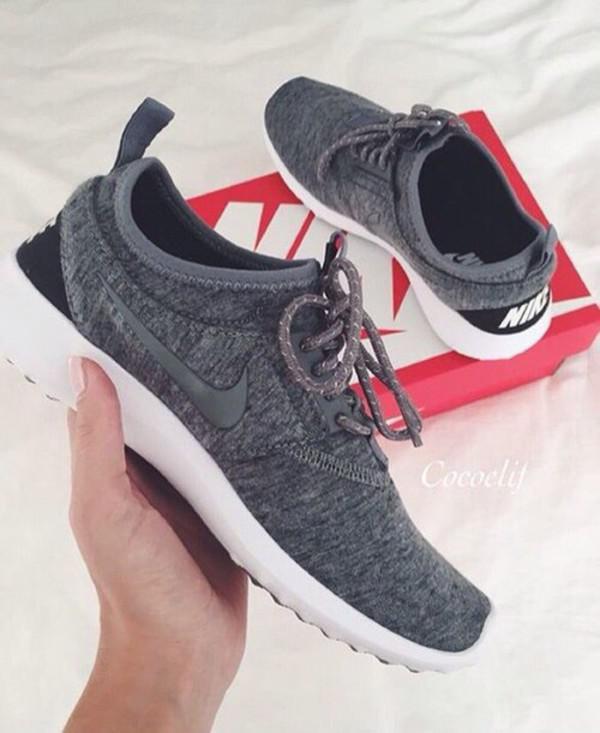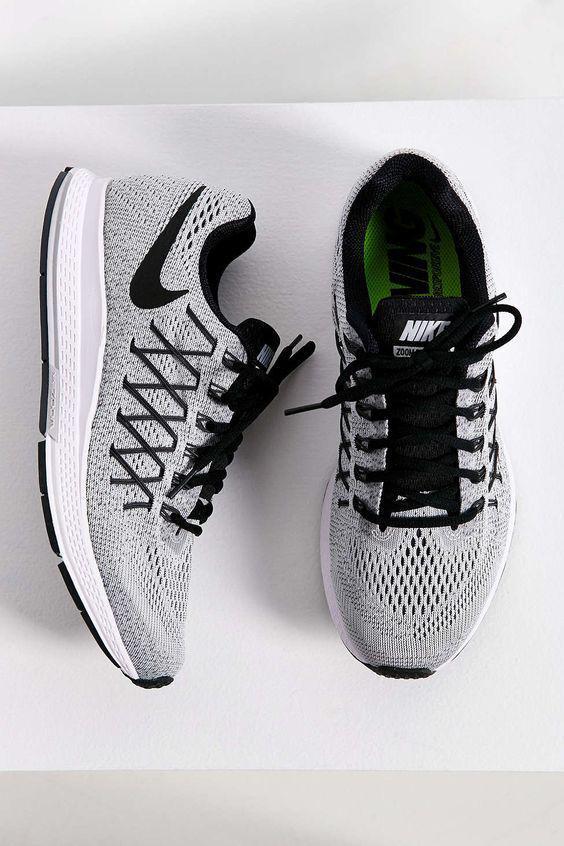The first image is the image on the left, the second image is the image on the right. Analyze the images presented: Is the assertion "In the right image, the shoe on the right has a swoop design visible." valid? Answer yes or no. No. 